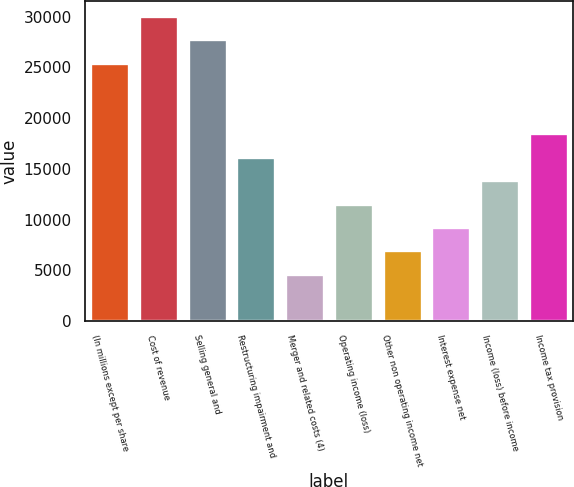Convert chart to OTSL. <chart><loc_0><loc_0><loc_500><loc_500><bar_chart><fcel>(In millions except per share<fcel>Cost of revenue<fcel>Selling general and<fcel>Restructuring impairment and<fcel>Merger and related costs (4)<fcel>Operating income (loss)<fcel>Other non operating income net<fcel>Interest expense net<fcel>Income (loss) before income<fcel>Income tax provision<nl><fcel>25445<fcel>30069<fcel>27757<fcel>16197<fcel>4637<fcel>11573<fcel>6949<fcel>9261<fcel>13885<fcel>18509<nl></chart> 